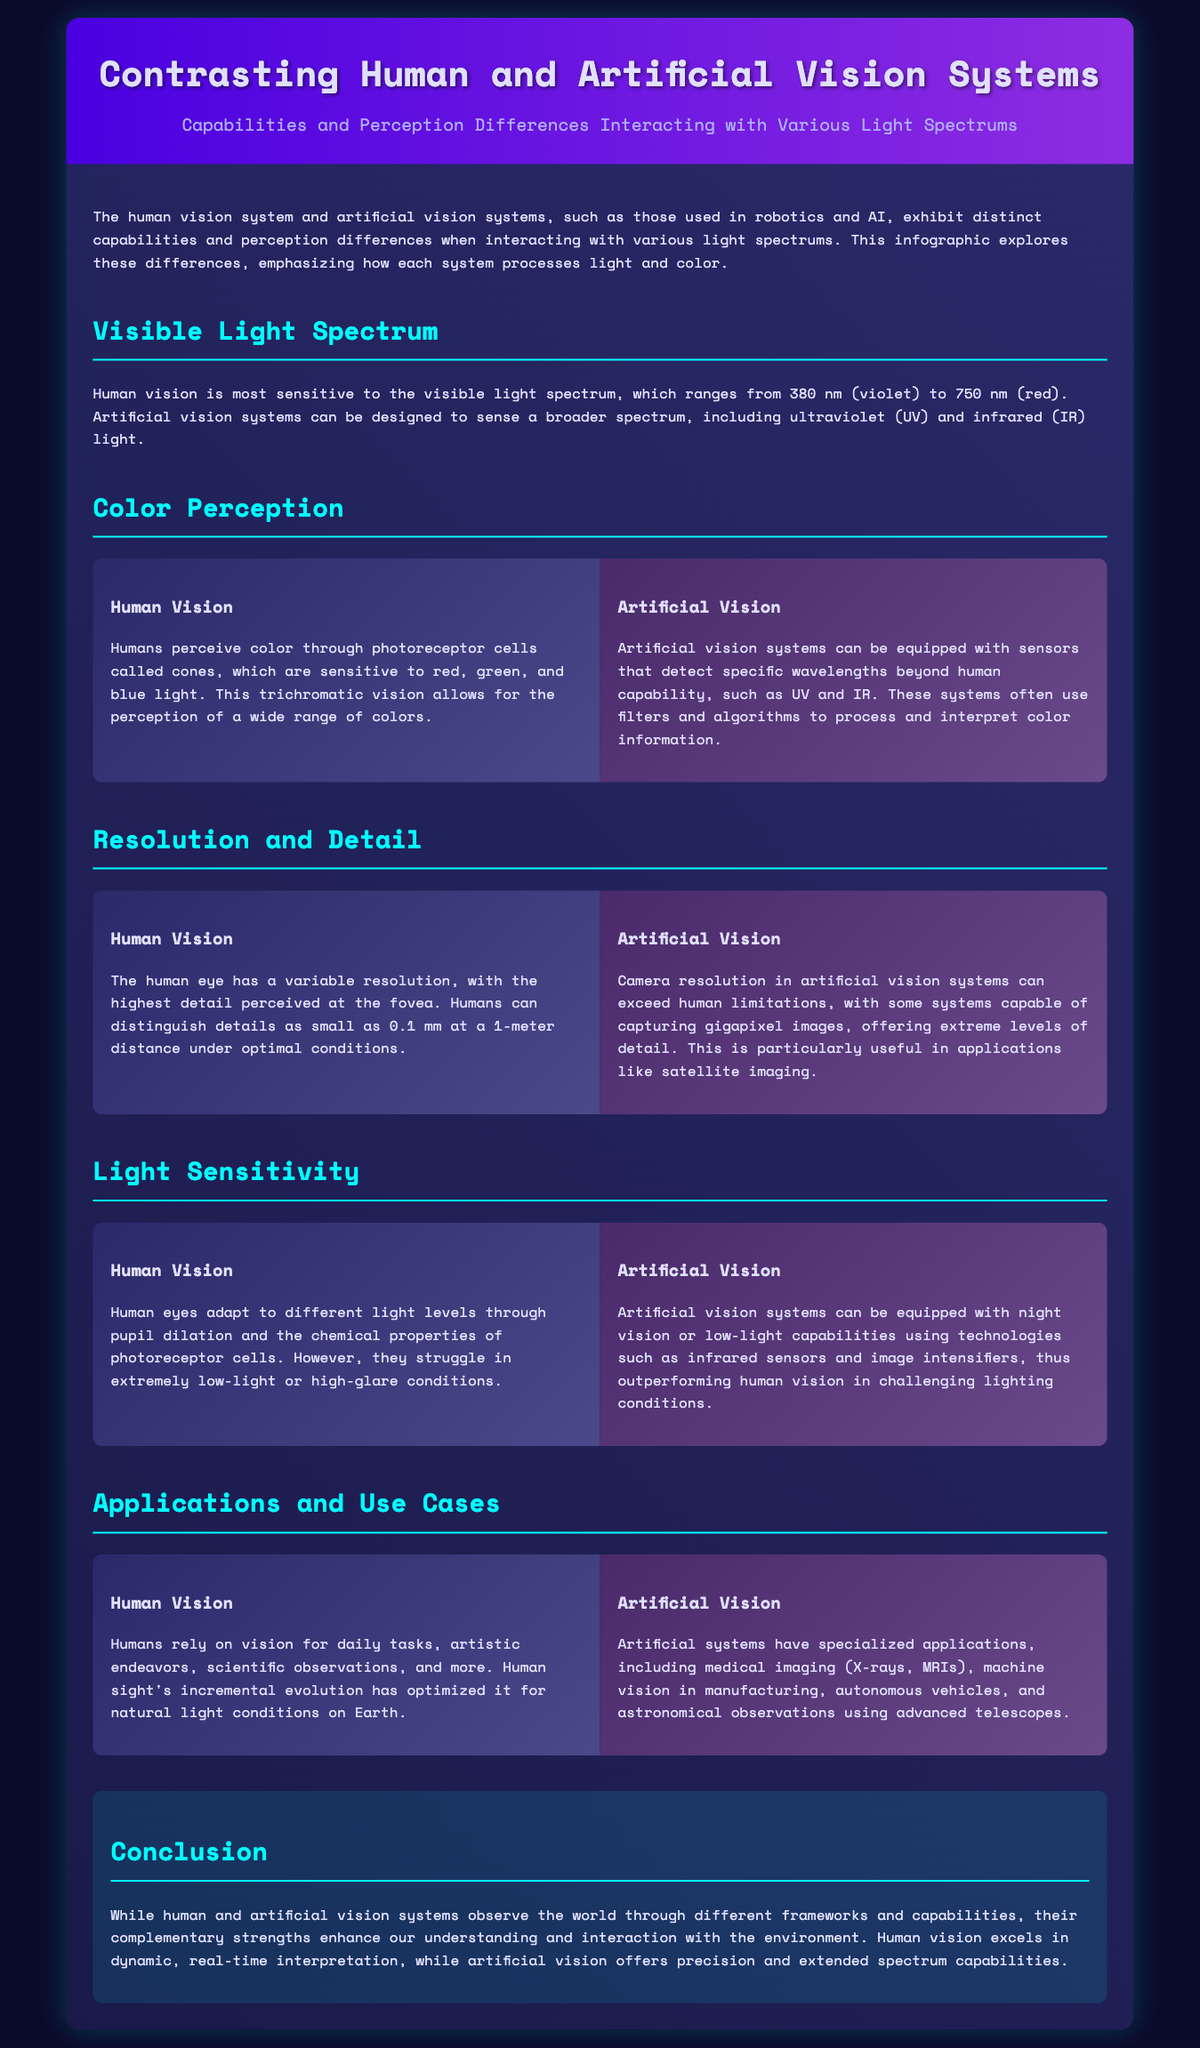what is the wavelength range of visible light? The visible light spectrum ranges from 380 nm (violet) to 750 nm (red).
Answer: 380 nm to 750 nm how do humans perceive color? Humans perceive color through photoreceptor cells called cones, sensitive to red, green, and blue light.
Answer: Cones what is the highest detail humans can distinguish? Humans can distinguish details as small as 0.1 mm at a 1-meter distance under optimal conditions.
Answer: 0.1 mm what is a capability of artificial vision systems? Artificial vision systems can be designed to sense a broader spectrum, including ultraviolet (UV) and infrared (IR) light.
Answer: UV and IR light which vision system outperforms in low-light conditions? Artificial vision systems can be equipped with night vision or low-light capabilities, outperforming human vision.
Answer: Artificial vision systems what is a common application of human vision? Humans rely on vision for daily tasks, artistic endeavors, and scientific observations.
Answer: Daily tasks which imaging technique is mentioned for artificial vision applications? Medical imaging techniques mentioned include X-rays and MRIs.
Answer: X-rays and MRIs what allows humans to adapt to different light levels? Human eyes adapt to different light levels through pupil dilation and the chemical properties of photoreceptor cells.
Answer: Pupil dilation how do artificial vision systems capture more detail? Some artificial vision systems are capable of capturing gigapixel images.
Answer: Gigapixel images 